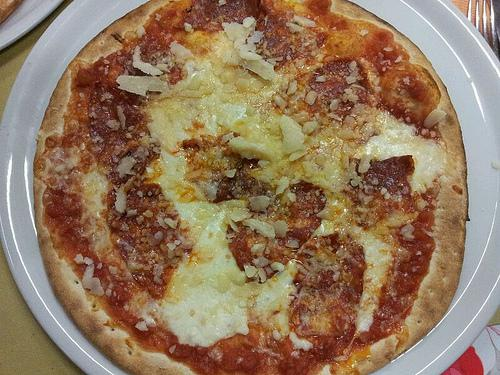Question: who is present?
Choices:
A. The lawyer.
B. No one.
C. The judge.
D. The defendant.
Answer with the letter. Answer: B Question: why is there food?
Choices:
A. To taste.
B. To be eaten.
C. To enjoy.
D. To sustain life.
Answer with the letter. Answer: B Question: what is on the plate?
Choices:
A. A sandwhich.
B. A salad.
C. Food.
D. A cookie.
Answer with the letter. Answer: C 